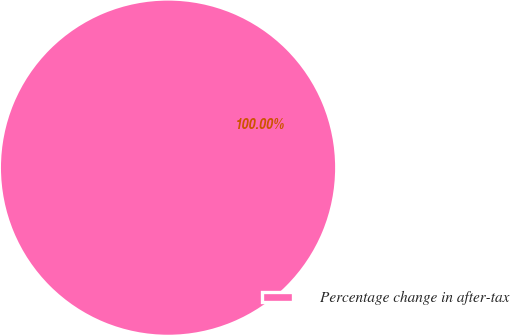Convert chart to OTSL. <chart><loc_0><loc_0><loc_500><loc_500><pie_chart><fcel>Percentage change in after-tax<nl><fcel>100.0%<nl></chart> 